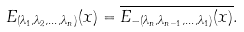Convert formula to latex. <formula><loc_0><loc_0><loc_500><loc_500>E _ { ( \lambda _ { 1 } , \lambda _ { 2 } , \dots , \lambda _ { n } ) } ( x ) = \overline { E _ { - ( \lambda _ { n } , \lambda _ { n - 1 } , \dots , \lambda _ { 1 } ) } ( x ) } .</formula> 